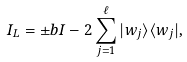Convert formula to latex. <formula><loc_0><loc_0><loc_500><loc_500>I _ { L } = \pm b { I } - 2 \sum ^ { \ell } _ { j = 1 } | w _ { j } \rangle \langle w _ { j } | ,</formula> 